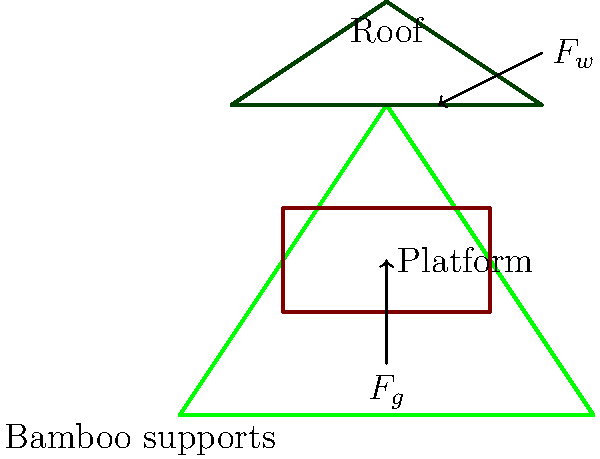Based on backpackers' experiences in eco-lodges, analyze the structural integrity of a bamboo treehouse. If the wind force ($F_w$) acting on the roof is 2 kN and the gravitational force ($F_g$) of the platform and occupants is 5 kN, what is the minimum diameter of the bamboo supports required to withstand these forces, assuming a maximum allowable stress of 20 MPa for bamboo? To determine the minimum diameter of the bamboo supports, we'll follow these steps:

1. Identify the forces: Wind force ($F_w$ = 2 kN) and gravitational force ($F_g$ = 5 kN).

2. Calculate the resultant force ($F_R$):
   $F_R = \sqrt{F_w^2 + F_g^2} = \sqrt{2^2 + 5^2} = \sqrt{4 + 25} = \sqrt{29} \approx 5.39$ kN

3. Assume two bamboo supports share the load equally:
   Force per support = $F_R / 2 = 5.39 / 2 \approx 2.695$ kN

4. Use the stress formula: $\sigma = F / A$, where $\sigma$ is the stress, $F$ is the force, and $A$ is the cross-sectional area.

5. Rearrange the formula to solve for area: $A = F / \sigma$
   $A = 2695 \text{ N} / (20 \times 10^6 \text{ Pa}) = 1.3475 \times 10^{-4} \text{ m}^2$

6. Calculate the required radius ($r$) using the area formula for a circle: $A = \pi r^2$
   $r = \sqrt{A / \pi} = \sqrt{1.3475 \times 10^{-4} / \pi} \approx 0.00655 \text{ m}$

7. Convert radius to diameter: $d = 2r \approx 0.0131 \text{ m} = 13.1 \text{ mm}$

Therefore, the minimum diameter of each bamboo support should be approximately 13.1 mm.
Answer: 13.1 mm 